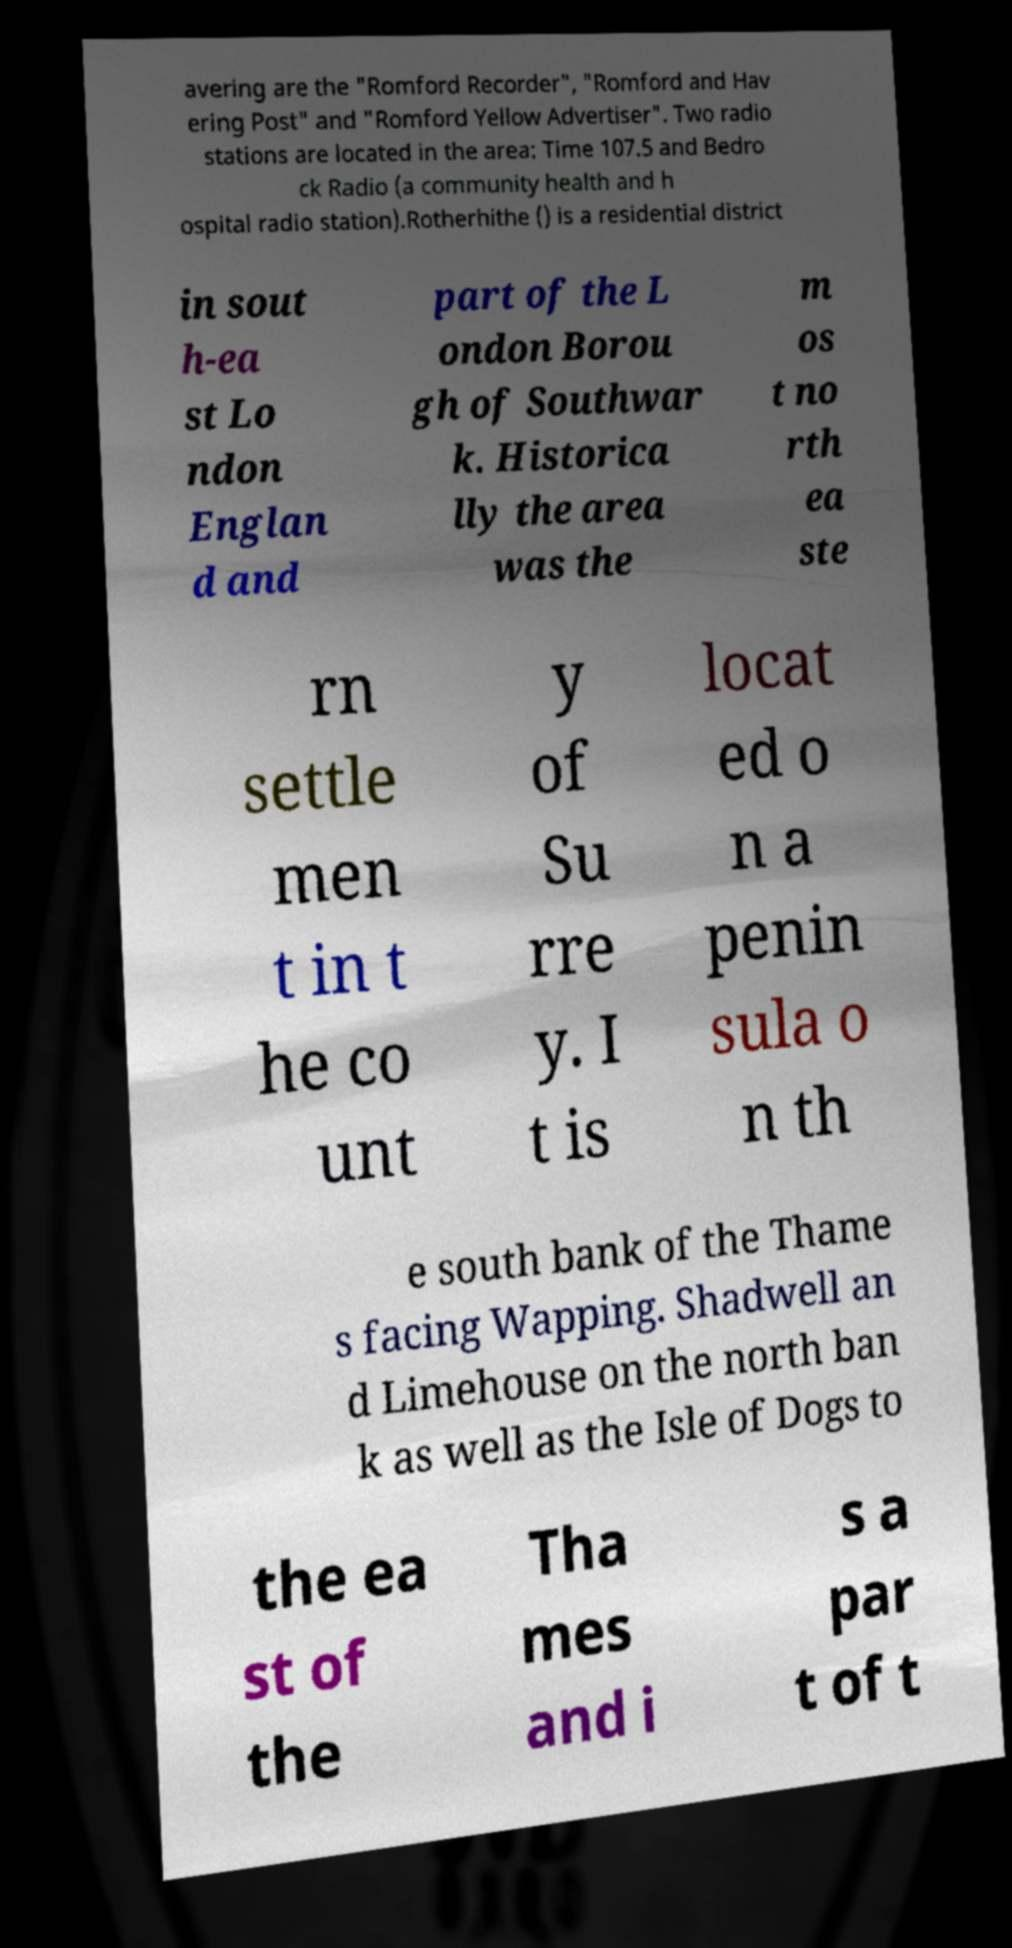I need the written content from this picture converted into text. Can you do that? avering are the "Romford Recorder", "Romford and Hav ering Post" and "Romford Yellow Advertiser". Two radio stations are located in the area: Time 107.5 and Bedro ck Radio (a community health and h ospital radio station).Rotherhithe () is a residential district in sout h-ea st Lo ndon Englan d and part of the L ondon Borou gh of Southwar k. Historica lly the area was the m os t no rth ea ste rn settle men t in t he co unt y of Su rre y. I t is locat ed o n a penin sula o n th e south bank of the Thame s facing Wapping. Shadwell an d Limehouse on the north ban k as well as the Isle of Dogs to the ea st of the Tha mes and i s a par t of t 